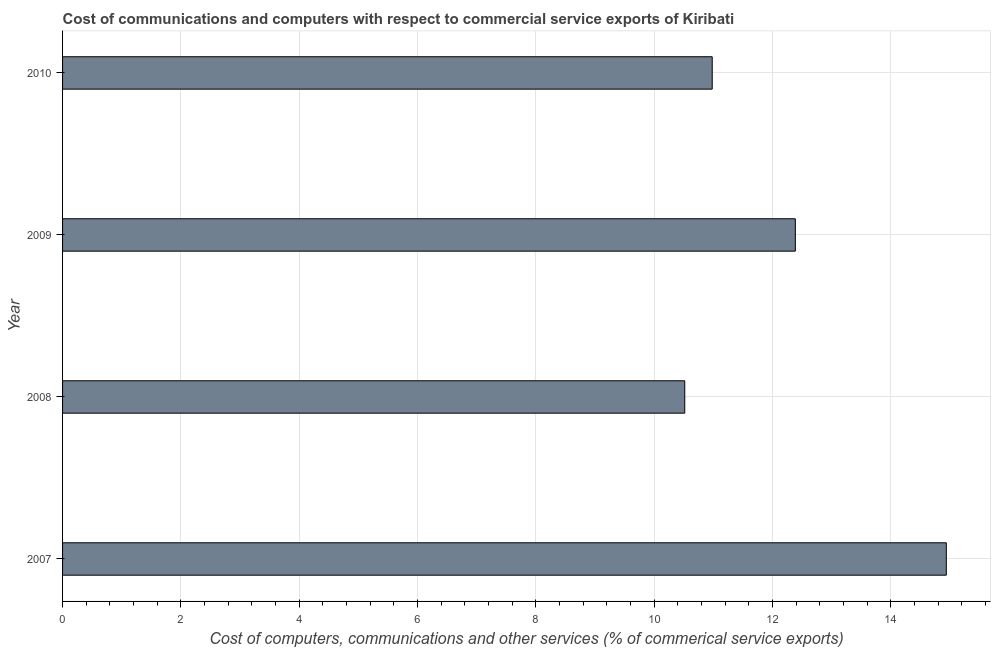What is the title of the graph?
Your response must be concise. Cost of communications and computers with respect to commercial service exports of Kiribati. What is the label or title of the X-axis?
Offer a terse response. Cost of computers, communications and other services (% of commerical service exports). What is the  computer and other services in 2007?
Offer a terse response. 14.94. Across all years, what is the maximum  computer and other services?
Ensure brevity in your answer.  14.94. Across all years, what is the minimum  computer and other services?
Provide a short and direct response. 10.52. In which year was the  computer and other services maximum?
Ensure brevity in your answer.  2007. In which year was the  computer and other services minimum?
Ensure brevity in your answer.  2008. What is the sum of the  computer and other services?
Give a very brief answer. 48.82. What is the difference between the  computer and other services in 2008 and 2009?
Ensure brevity in your answer.  -1.87. What is the average  computer and other services per year?
Your response must be concise. 12.2. What is the median  computer and other services?
Provide a short and direct response. 11.68. Do a majority of the years between 2008 and 2009 (inclusive) have  computer and other services greater than 3.6 %?
Provide a succinct answer. Yes. What is the ratio of the cost of communications in 2007 to that in 2009?
Provide a short and direct response. 1.21. Is the cost of communications in 2009 less than that in 2010?
Your answer should be very brief. No. What is the difference between the highest and the second highest cost of communications?
Your answer should be very brief. 2.55. What is the difference between the highest and the lowest  computer and other services?
Keep it short and to the point. 4.42. How many years are there in the graph?
Provide a short and direct response. 4. What is the difference between two consecutive major ticks on the X-axis?
Your response must be concise. 2. What is the Cost of computers, communications and other services (% of commerical service exports) in 2007?
Offer a terse response. 14.94. What is the Cost of computers, communications and other services (% of commerical service exports) of 2008?
Give a very brief answer. 10.52. What is the Cost of computers, communications and other services (% of commerical service exports) of 2009?
Provide a short and direct response. 12.38. What is the Cost of computers, communications and other services (% of commerical service exports) of 2010?
Give a very brief answer. 10.98. What is the difference between the Cost of computers, communications and other services (% of commerical service exports) in 2007 and 2008?
Provide a succinct answer. 4.42. What is the difference between the Cost of computers, communications and other services (% of commerical service exports) in 2007 and 2009?
Provide a succinct answer. 2.55. What is the difference between the Cost of computers, communications and other services (% of commerical service exports) in 2007 and 2010?
Your answer should be very brief. 3.96. What is the difference between the Cost of computers, communications and other services (% of commerical service exports) in 2008 and 2009?
Make the answer very short. -1.87. What is the difference between the Cost of computers, communications and other services (% of commerical service exports) in 2008 and 2010?
Ensure brevity in your answer.  -0.46. What is the difference between the Cost of computers, communications and other services (% of commerical service exports) in 2009 and 2010?
Give a very brief answer. 1.41. What is the ratio of the Cost of computers, communications and other services (% of commerical service exports) in 2007 to that in 2008?
Make the answer very short. 1.42. What is the ratio of the Cost of computers, communications and other services (% of commerical service exports) in 2007 to that in 2009?
Ensure brevity in your answer.  1.21. What is the ratio of the Cost of computers, communications and other services (% of commerical service exports) in 2007 to that in 2010?
Your response must be concise. 1.36. What is the ratio of the Cost of computers, communications and other services (% of commerical service exports) in 2008 to that in 2009?
Ensure brevity in your answer.  0.85. What is the ratio of the Cost of computers, communications and other services (% of commerical service exports) in 2008 to that in 2010?
Your response must be concise. 0.96. What is the ratio of the Cost of computers, communications and other services (% of commerical service exports) in 2009 to that in 2010?
Keep it short and to the point. 1.13. 